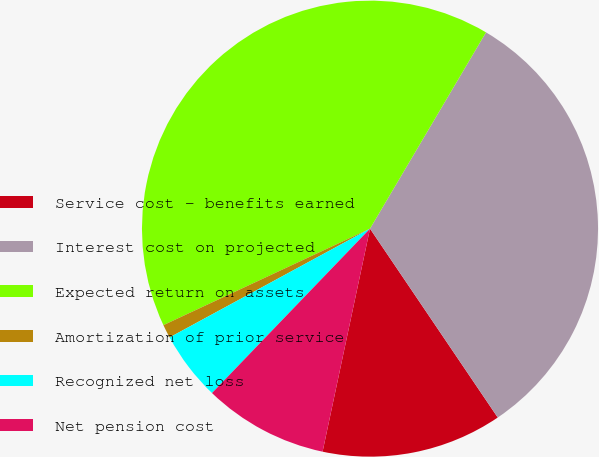Convert chart to OTSL. <chart><loc_0><loc_0><loc_500><loc_500><pie_chart><fcel>Service cost - benefits earned<fcel>Interest cost on projected<fcel>Expected return on assets<fcel>Amortization of prior service<fcel>Recognized net loss<fcel>Net pension cost<nl><fcel>12.8%<fcel>32.04%<fcel>40.45%<fcel>0.96%<fcel>4.9%<fcel>8.85%<nl></chart> 